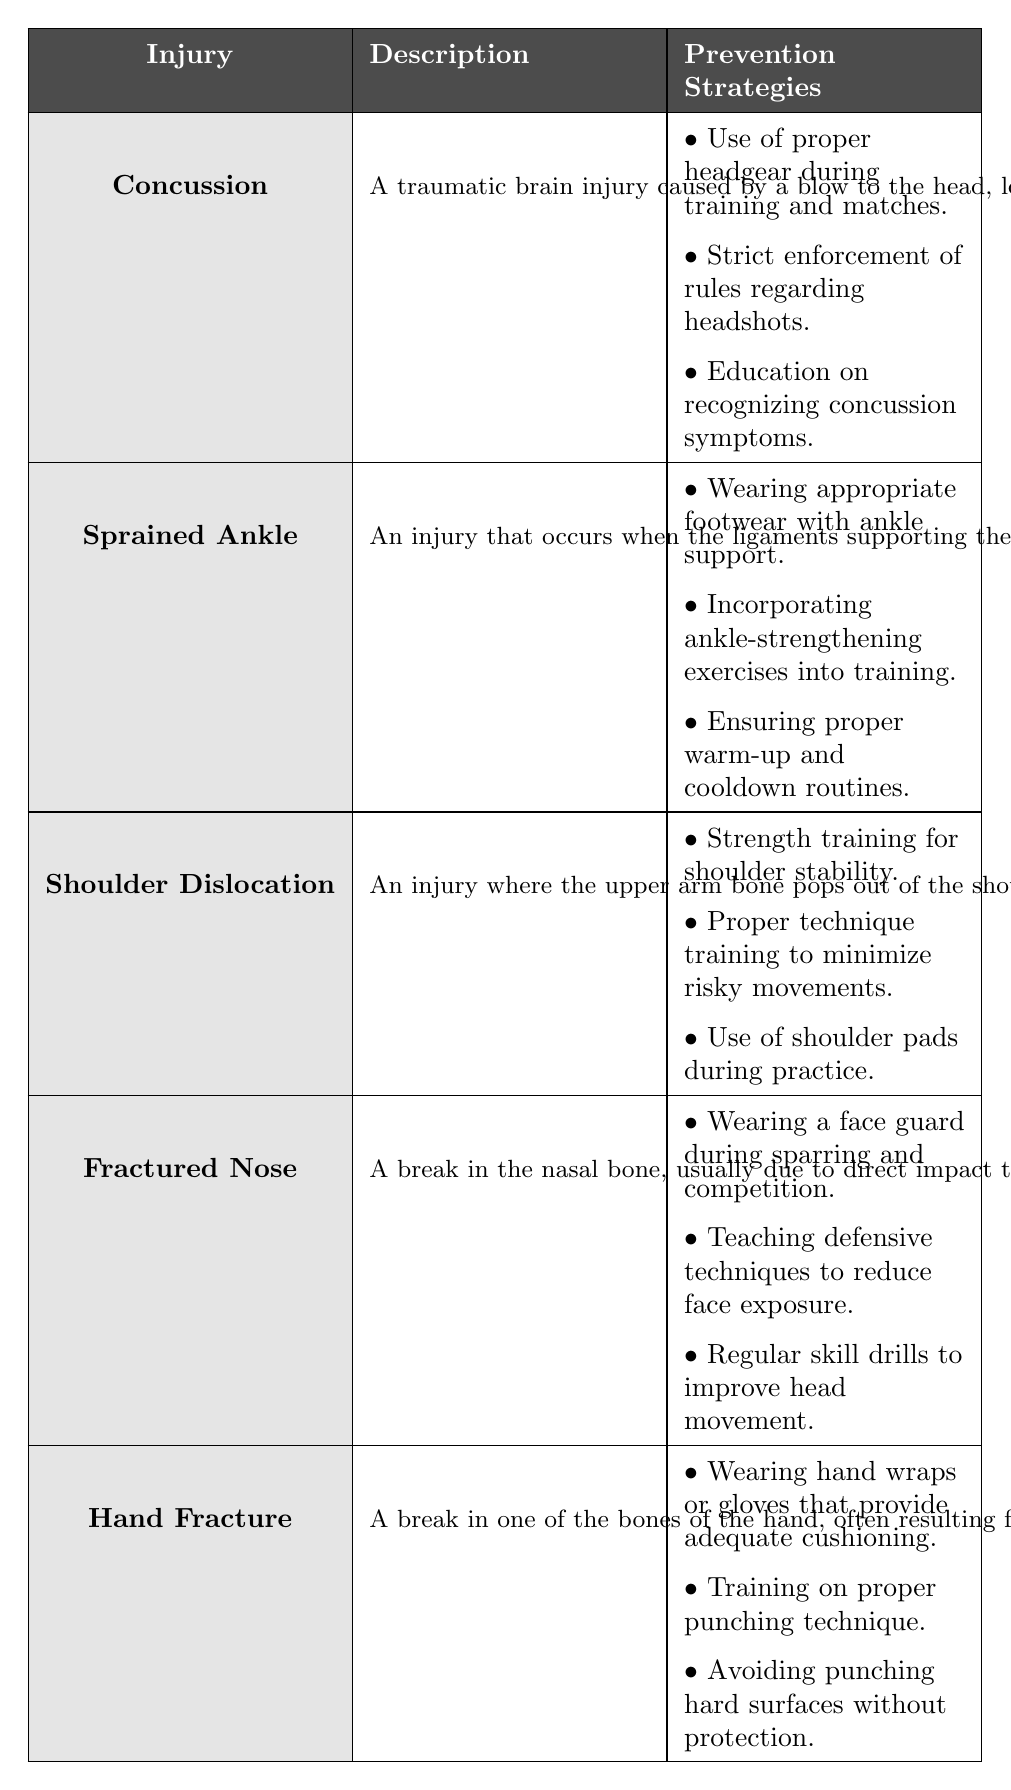What is the description of a concussion? The table provides a description of each injury. For concussion, it states that it is "a traumatic brain injury caused by a blow to the head, leading to symptoms such as headache, confusion, dizziness, and memory problems."
Answer: A concussion is a traumatic brain injury caused by a blow to the head What are the prevention strategies for a fractured nose? To find this information, I look at the row corresponding to a fractured nose. The prevention strategies listed are: wearing a face guard during sparring and competition, teaching defensive techniques to reduce face exposure, and regular skill drills to improve head movement.
Answer: Wearing a face guard, teaching defensive techniques, regular skill drills Is wearing hand wraps a prevention strategy for hand fractures? By reviewing the prevention strategies listed for hand fractures, one of the strategies explicitly states, "Wearing hand wraps or gloves that provide adequate cushioning."
Answer: Yes Which injury has prevention strategies involving shoulder pads? I can scan the table for injuries and their corresponding prevention strategies. The injury that mentions the use of shoulder pads during practice is "Shoulder Dislocation."
Answer: Shoulder Dislocation What are the total number of prevention strategies listed for each injury? I need to count the prevention strategies for each injury in the table: Concussion has 3, Sprained Ankle has 3, Shoulder Dislocation has 3, Fractured Nose has 3, and Hand Fracture has 3. Thus, each injury has the same number of strategies.
Answer: Each injury has 3 prevention strategies If a boxer follows all the prevention strategies for a sprained ankle, how many total strategies does he need to follow? For a sprained ankle, the table lists three prevention strategies: wearing appropriate footwear with ankle support, incorporating ankle-strengthening exercises into training, and ensuring proper warm-up and cooldown routines. Therefore, the total is 3.
Answer: 3 Are there more injuries listed that require head protection than those that require hand protection? To answer this, I examine the injuries: Concussion and Fractured Nose require head protection, while Hand Fracture is the only one that requires hand protection. This indicates that there are two that require head protection and one for hand protection.
Answer: Yes What injury description is associated with the need for strength training? Looking at the prevention strategies for each injury, I find that "Strength training for shoulder stability" is mentioned in the prevention strategies for "Shoulder Dislocation."
Answer: Shoulder Dislocation Which injury has a description that involves direct impact to the face? By reviewing the descriptions in the table, the injury that mentions a break in the nasal bone due to direct impact to the face is "Fractured Nose."
Answer: Fractured Nose How many total injuries are listed in the table? From the table, I can count the number of injury entries: Concussion, Sprained Ankle, Shoulder Dislocation, Fractured Nose, and Hand Fracture. This sums up to 5 injuries.
Answer: 5 